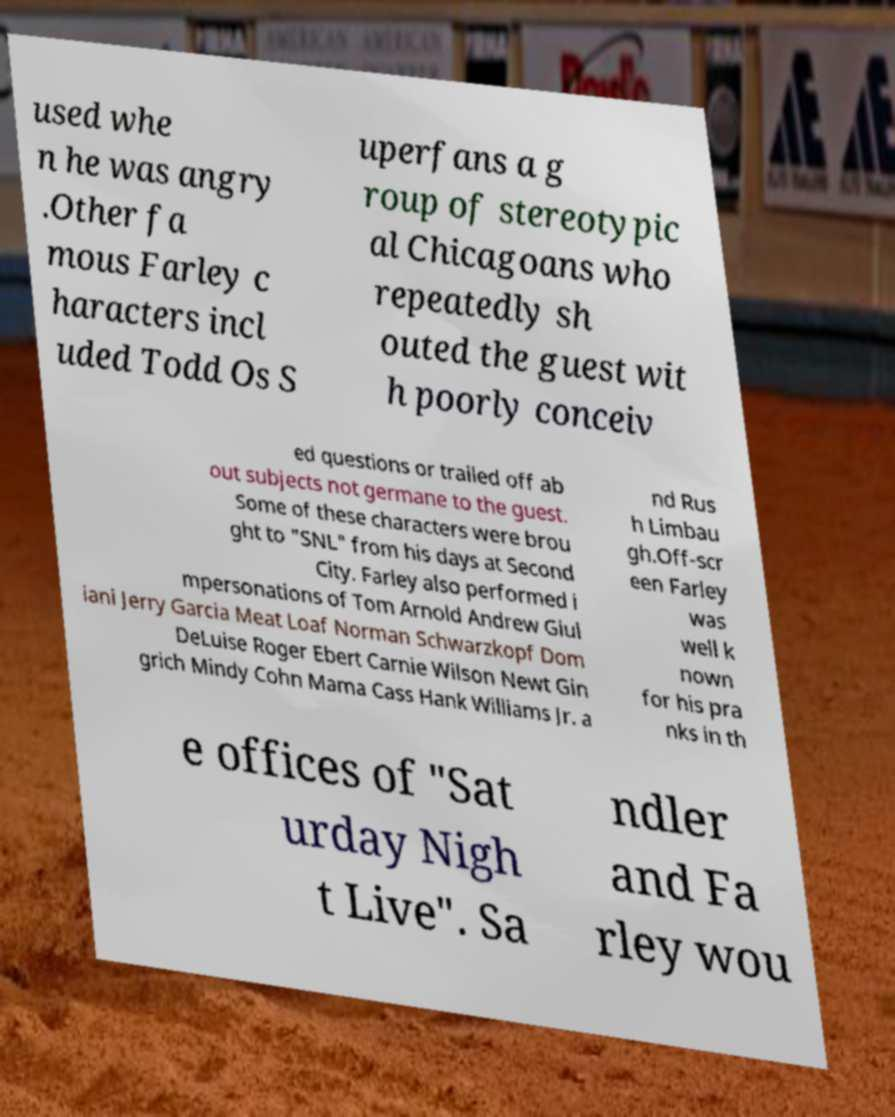Can you accurately transcribe the text from the provided image for me? used whe n he was angry .Other fa mous Farley c haracters incl uded Todd Os S uperfans a g roup of stereotypic al Chicagoans who repeatedly sh outed the guest wit h poorly conceiv ed questions or trailed off ab out subjects not germane to the guest. Some of these characters were brou ght to "SNL" from his days at Second City. Farley also performed i mpersonations of Tom Arnold Andrew Giul iani Jerry Garcia Meat Loaf Norman Schwarzkopf Dom DeLuise Roger Ebert Carnie Wilson Newt Gin grich Mindy Cohn Mama Cass Hank Williams Jr. a nd Rus h Limbau gh.Off-scr een Farley was well k nown for his pra nks in th e offices of "Sat urday Nigh t Live". Sa ndler and Fa rley wou 